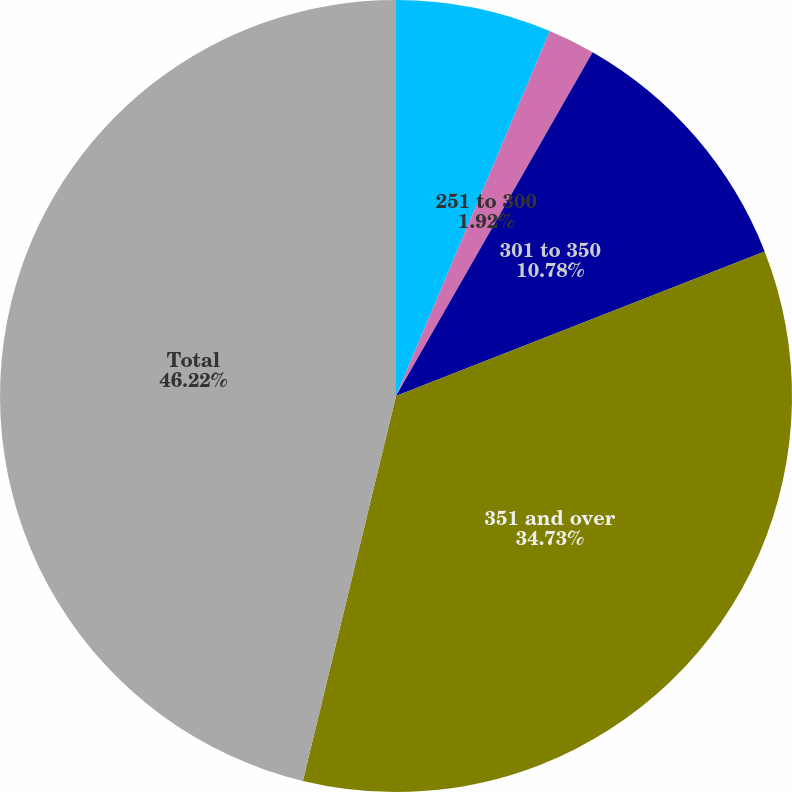Convert chart to OTSL. <chart><loc_0><loc_0><loc_500><loc_500><pie_chart><fcel>201 to 250<fcel>251 to 300<fcel>301 to 350<fcel>351 and over<fcel>Total<nl><fcel>6.35%<fcel>1.92%<fcel>10.78%<fcel>34.73%<fcel>46.22%<nl></chart> 